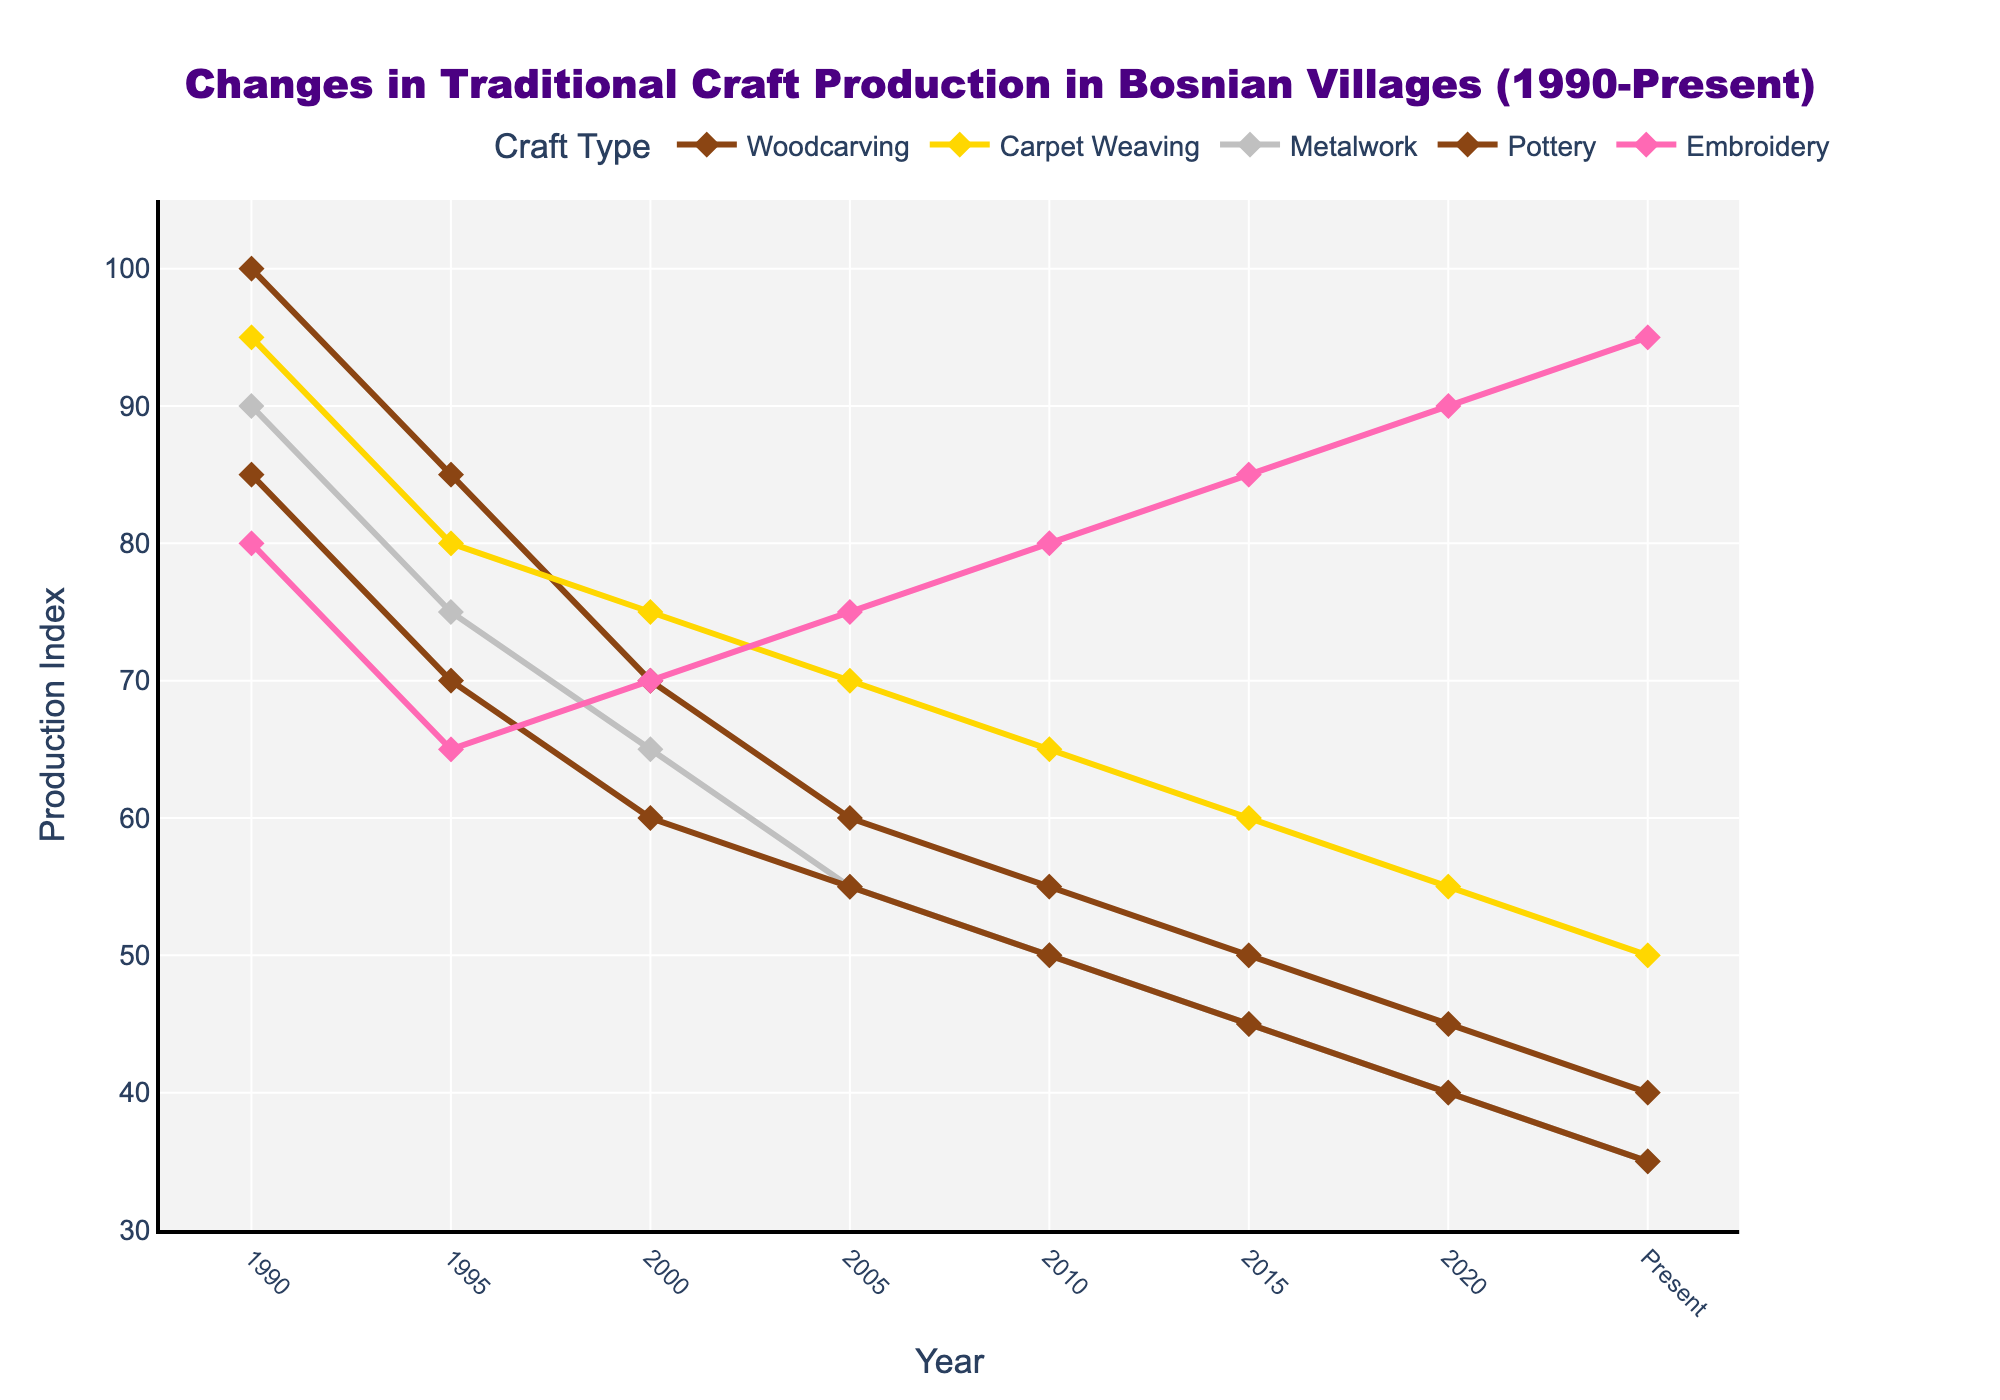What was the production index for Woodcarving and Pottery in 1990, and what is the difference between them? The production index for Woodcarving in 1990 was 100, and for Pottery, it was 85. The difference between them is 100 - 85 = 15.
Answer: 15 Between which years did Carpet Weaving see the greatest decline in production index? Carpet Weaving saw the greatest decline between 1990 (95) and 1995 (80), which is a decrease of 95 - 80 = 15.
Answer: 1990 to 1995 Which craft type had the highest production index in the present year? According to the chart, Embroidery had the highest production index in the present year at 95.
Answer: Embroidery What trend do you notice for the Metalwork production from 1995 to 2015? The trend for Metalwork production shows a continuous decline from 1995 (75) to 2015 (45).
Answer: Decline By how much did the Embroidery production index increase from 1990 to the present? The Embroidery production index increased from 80 in 1990 to 95 in the present. The increase is 95 - 80 = 15.
Answer: 15 Comparing the production indices of Carpeting Weaving and Woodcarving in 2020, which one is higher and by how much? In 2020, the production index for Carpet Weaving is 55, while for Woodcarving it is 45. Carpet Weaving is higher by 55 - 45 = 10.
Answer: Carpet Weaving by 10 What is the average production index of Pottery from 1990 to the present? The production indices for Pottery from 1990 to the present are 85, 70, 60, 55, 50, 45, 40, and 35. The sum is 85 + 70 + 60 + 55 + 50 + 45 + 40 + 35 = 440, and there are 8 values. The average is 440 / 8 = 55.
Answer: 55 Which craft type shows a consistently increasing production index trend from 1990 to the present? The only craft type with a consistently increasing trend from 1990 to the present is Embroidery, which rises from 80 to 95.
Answer: Embroidery In which year did Woodcarving production experience a significant drop? Woodcarving production experienced a significant drop between 1990 (100) and 1995 (85).
Answer: 1990 to 1995 What is the total production index for all craft types in the present year? The production indices in the present year are Woodcarving 40, Carpet Weaving 50, Metalwork 35, Pottery 35, and Embroidery 95. The total is 40 + 50 + 35 + 35 + 95 = 255.
Answer: 255 